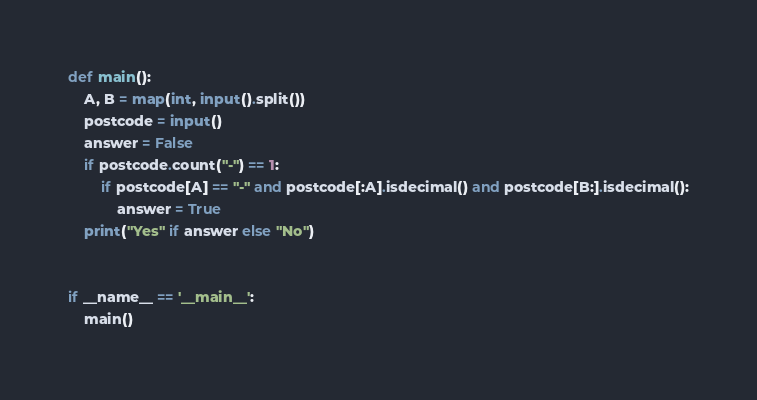Convert code to text. <code><loc_0><loc_0><loc_500><loc_500><_Python_>def main():
    A, B = map(int, input().split())
    postcode = input()
    answer = False
    if postcode.count("-") == 1:
        if postcode[A] == "-" and postcode[:A].isdecimal() and postcode[B:].isdecimal():
            answer = True
    print("Yes" if answer else "No")


if __name__ == '__main__':
    main()</code> 